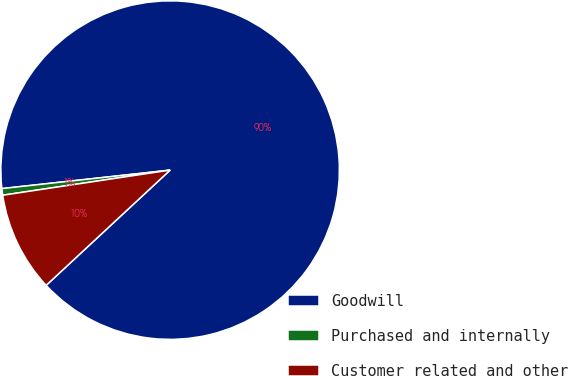<chart> <loc_0><loc_0><loc_500><loc_500><pie_chart><fcel>Goodwill<fcel>Purchased and internally<fcel>Customer related and other<nl><fcel>89.83%<fcel>0.63%<fcel>9.55%<nl></chart> 